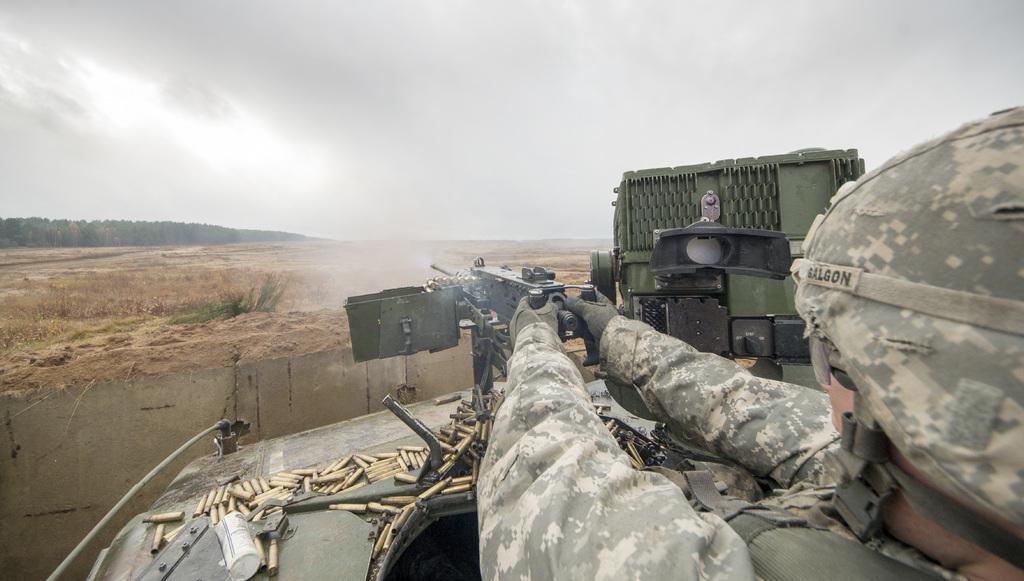Could you give a brief overview of what you see in this image? In this image there is the sky truncated towards the top of the image, there are trees truncated towards the left of the image, there are plants, there is a vehicle truncated towards the bottom of the image, there is a person truncated towards the bottom of the image, the person is holding a gun, there are objects in the vehicle. 